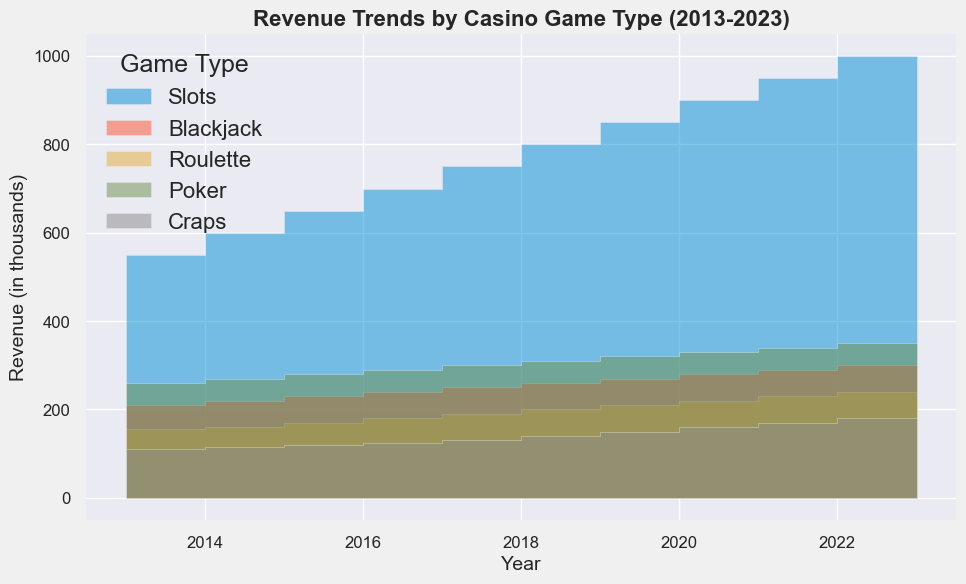What year did Slots revenue reach 800 thousand? By looking at the area chart, find the year when the Slots area reaches the 800 thousand mark. Trace back vertically from the point where 800 is marked on the y-axis to find the corresponding year on the x-axis.
Answer: 2019 Which game showed the steepest increase in revenue from 2013 to 2023? Analyze the slope of the areas representing each game type. The steepest increase will have the sharpest upward slope. Slots have the steepest increase from 500 in 2013 to 1000 in 2023.
Answer: Slots Compare the revenues of Poker and Craps in 2017. Which one was higher and by how much? To compare, first find the revenue for Poker in 2017, which is 290 thousand, and for Craps, it is 125 thousand. Subtract Craps revenue from Poker revenue to find the difference. 290 - 125 = 165
Answer: Poker, 165 thousand What is the average annual increase in revenue for Blackjack from 2013 to 2023? Calculate the total increase over the period: 300 (2023) - 200 (2013) = 100. Then divide this increase by the number of years (2023-2013=10 years). So, 100 / 10 = 10
Answer: 10 thousand per year What is the combined revenue of all games in 2023? Sum the revenues for all games for the year 2023: Slots (1000) + Blackjack (300) + Roulette (240) + Poker (350) + Craps (180). Thus, 1000 + 300 + 240 + 350 + 180 = 2070
Answer: 2070 thousand Which game had the smallest increase in revenue over the decade? Compare the total increases for each game by subtracting 2013 values from 2023 values. Slots (1000-500=500), Blackjack (300-200=100), Roulette (240-150=90), Poker (350-250=100), Craps (180-100=80). The smallest increase is 80 for Craps.
Answer: Craps How did the revenue for Roulette change between 2015 and 2021? First, find the revenue for Roulette in 2015 (160) and 2021 (220). Subtract the earlier year's revenue from the later year's revenue: 220 - 160 = 60.
Answer: Increased by 60 thousand In what year did Poker revenue surpass 300 thousand? Look for the point on the chart where the Poker area exceeds 300 thousand. This occurs in 2021, which is the first year Poker revenue exceeds 300 thousand.
Answer: 2021 By how much did the revenue for Slots increase from 2013 to 2018? Find the revenue for Slots in 2013 (500) and 2018 (750), then subtract 2013 from 2018 to get the increase: 750 - 500 = 250.
Answer: 250 Which casino game had the smallest revenue in 2020, and what was it? By identifying the lowest area in the chart for 2020, we see it is Craps with a revenue of 150.
Answer: Craps, 150 thousand 